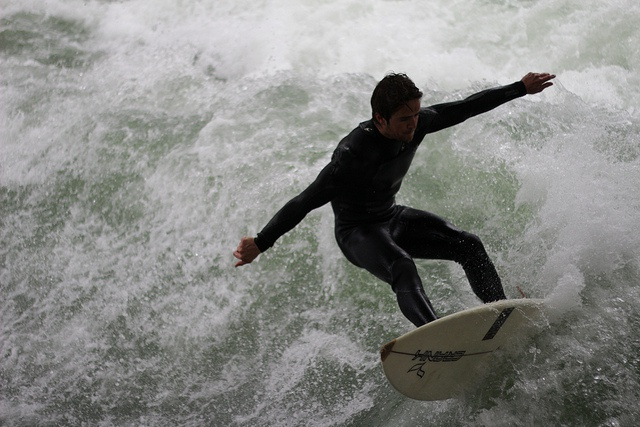Describe the objects in this image and their specific colors. I can see people in darkgray, black, gray, and lightgray tones and surfboard in darkgray, black, and gray tones in this image. 